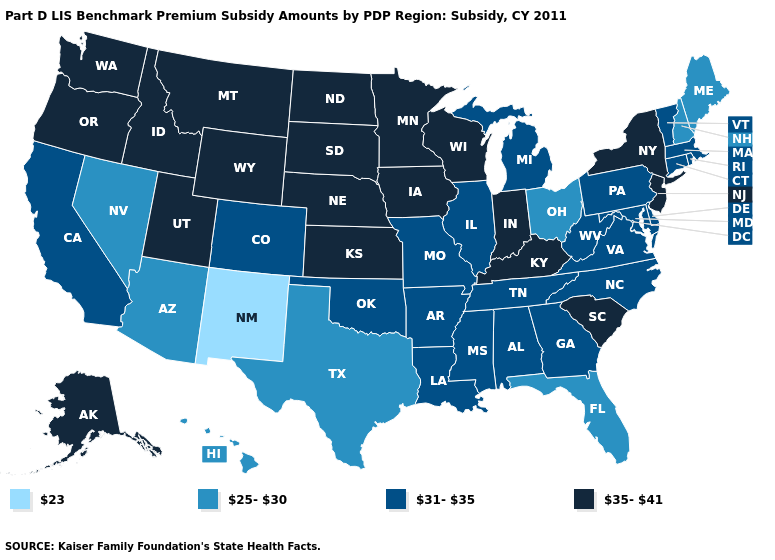Name the states that have a value in the range 23?
Quick response, please. New Mexico. Name the states that have a value in the range 35-41?
Answer briefly. Alaska, Idaho, Indiana, Iowa, Kansas, Kentucky, Minnesota, Montana, Nebraska, New Jersey, New York, North Dakota, Oregon, South Carolina, South Dakota, Utah, Washington, Wisconsin, Wyoming. What is the value of North Carolina?
Short answer required. 31-35. Which states have the highest value in the USA?
Quick response, please. Alaska, Idaho, Indiana, Iowa, Kansas, Kentucky, Minnesota, Montana, Nebraska, New Jersey, New York, North Dakota, Oregon, South Carolina, South Dakota, Utah, Washington, Wisconsin, Wyoming. What is the value of Wyoming?
Give a very brief answer. 35-41. What is the value of Michigan?
Quick response, please. 31-35. Name the states that have a value in the range 31-35?
Give a very brief answer. Alabama, Arkansas, California, Colorado, Connecticut, Delaware, Georgia, Illinois, Louisiana, Maryland, Massachusetts, Michigan, Mississippi, Missouri, North Carolina, Oklahoma, Pennsylvania, Rhode Island, Tennessee, Vermont, Virginia, West Virginia. What is the lowest value in the USA?
Concise answer only. 23. Does Iowa have the same value as Alaska?
Concise answer only. Yes. Which states have the lowest value in the USA?
Keep it brief. New Mexico. What is the value of Utah?
Concise answer only. 35-41. What is the value of Rhode Island?
Keep it brief. 31-35. What is the value of New Hampshire?
Quick response, please. 25-30. Which states have the highest value in the USA?
Short answer required. Alaska, Idaho, Indiana, Iowa, Kansas, Kentucky, Minnesota, Montana, Nebraska, New Jersey, New York, North Dakota, Oregon, South Carolina, South Dakota, Utah, Washington, Wisconsin, Wyoming. What is the value of Louisiana?
Give a very brief answer. 31-35. 